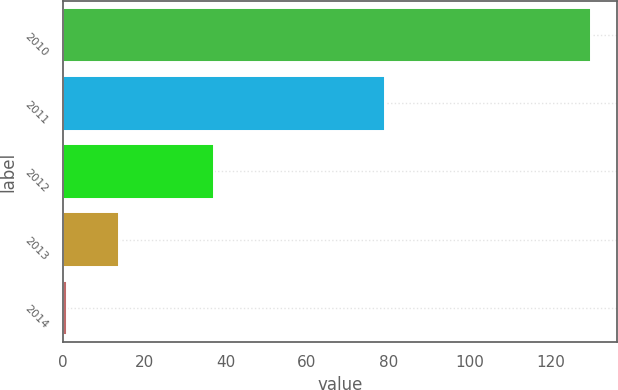<chart> <loc_0><loc_0><loc_500><loc_500><bar_chart><fcel>2010<fcel>2011<fcel>2012<fcel>2013<fcel>2014<nl><fcel>129.9<fcel>79.3<fcel>37.2<fcel>13.89<fcel>1<nl></chart> 